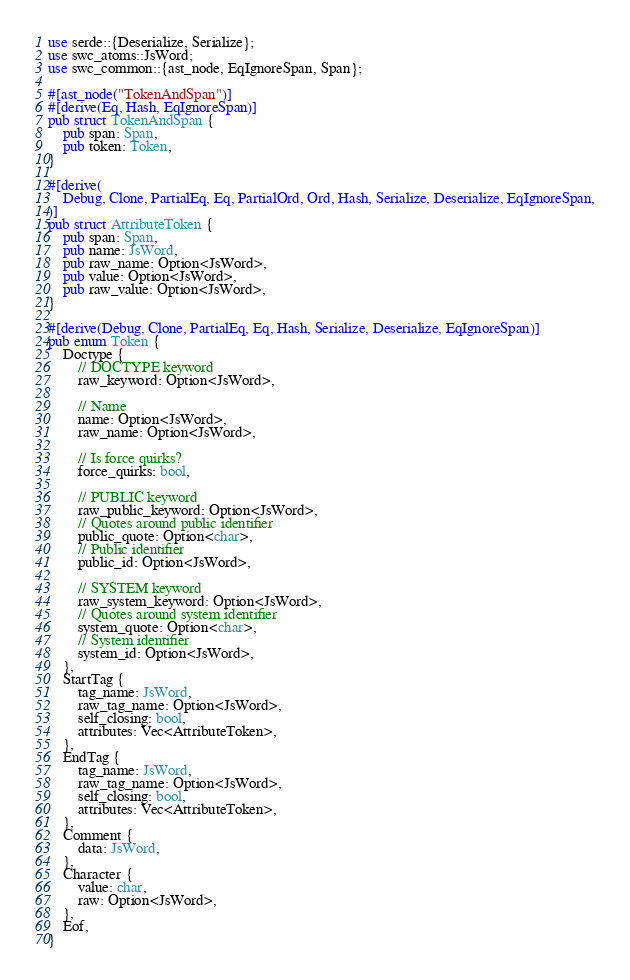<code> <loc_0><loc_0><loc_500><loc_500><_Rust_>use serde::{Deserialize, Serialize};
use swc_atoms::JsWord;
use swc_common::{ast_node, EqIgnoreSpan, Span};

#[ast_node("TokenAndSpan")]
#[derive(Eq, Hash, EqIgnoreSpan)]
pub struct TokenAndSpan {
    pub span: Span,
    pub token: Token,
}

#[derive(
    Debug, Clone, PartialEq, Eq, PartialOrd, Ord, Hash, Serialize, Deserialize, EqIgnoreSpan,
)]
pub struct AttributeToken {
    pub span: Span,
    pub name: JsWord,
    pub raw_name: Option<JsWord>,
    pub value: Option<JsWord>,
    pub raw_value: Option<JsWord>,
}

#[derive(Debug, Clone, PartialEq, Eq, Hash, Serialize, Deserialize, EqIgnoreSpan)]
pub enum Token {
    Doctype {
        // DOCTYPE keyword
        raw_keyword: Option<JsWord>,

        // Name
        name: Option<JsWord>,
        raw_name: Option<JsWord>,

        // Is force quirks?
        force_quirks: bool,

        // PUBLIC keyword
        raw_public_keyword: Option<JsWord>,
        // Quotes around public identifier
        public_quote: Option<char>,
        // Public identifier
        public_id: Option<JsWord>,

        // SYSTEM keyword
        raw_system_keyword: Option<JsWord>,
        // Quotes around system identifier
        system_quote: Option<char>,
        // System identifier
        system_id: Option<JsWord>,
    },
    StartTag {
        tag_name: JsWord,
        raw_tag_name: Option<JsWord>,
        self_closing: bool,
        attributes: Vec<AttributeToken>,
    },
    EndTag {
        tag_name: JsWord,
        raw_tag_name: Option<JsWord>,
        self_closing: bool,
        attributes: Vec<AttributeToken>,
    },
    Comment {
        data: JsWord,
    },
    Character {
        value: char,
        raw: Option<JsWord>,
    },
    Eof,
}
</code> 